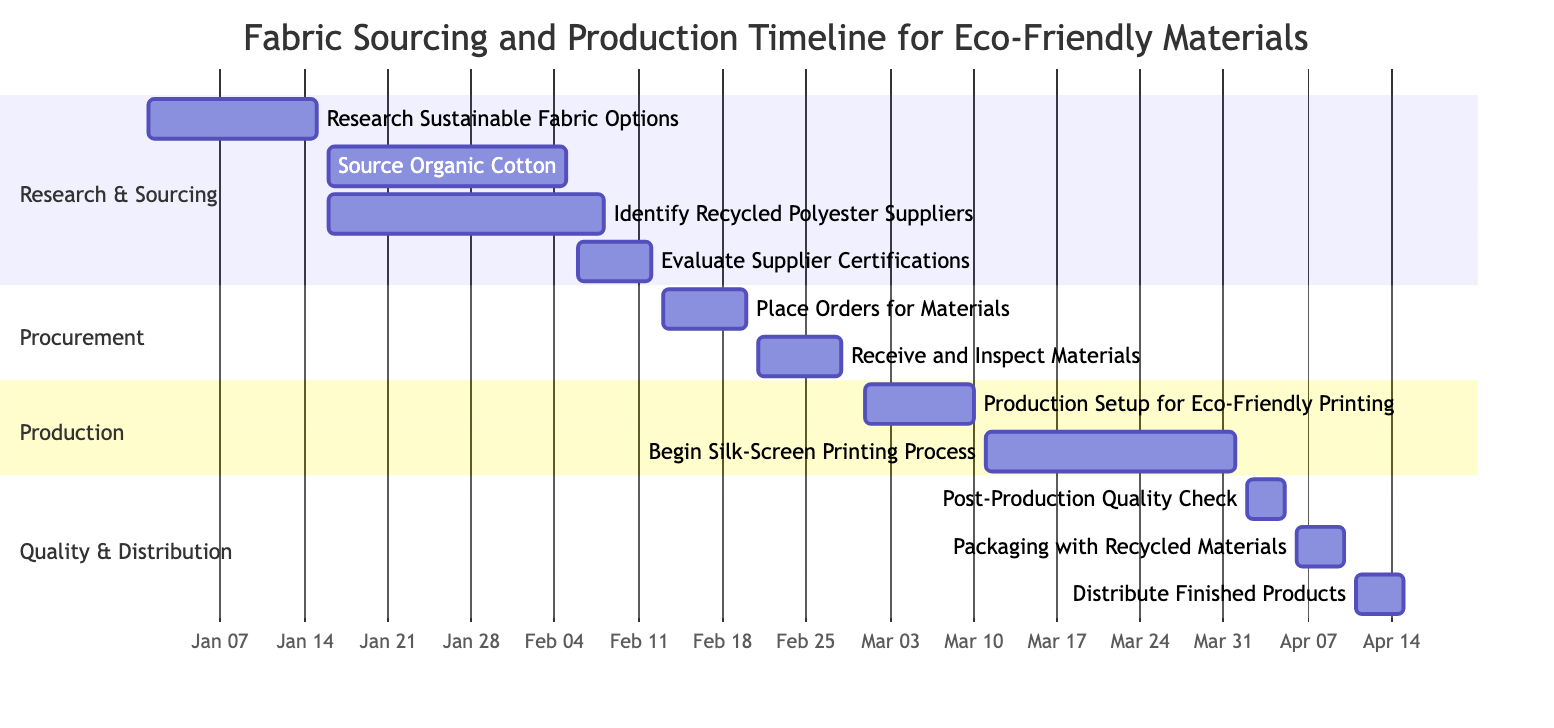What is the duration of the task "Source Organic Cotton"? The task "Source Organic Cotton" starts on January 16, 2024, and ends on February 5, 2024. To find the duration, count the days from the start date to the end date: from January 16 to February 5 is 20 days.
Answer: 20 days Which task overlaps with "Evaluate Supplier Certifications"? "Source Organic Cotton" runs from January 16 to February 5, and "Evaluate Supplier Certifications" runs from February 6 to February 12. There are no overlaps in their timelines, but it overlaps with "Identify Recycled Polyester Suppliers" which runs from January 16 to February 8.
Answer: "Identify Recycled Polyester Suppliers" How many total tasks are listed in the Gantt chart? By counting each task in the provided list, there are 11 tasks in total. Each task represents a specific part of the fabric sourcing and production process for eco-friendly materials.
Answer: 11 What task starts immediately after "Receive and Inspect Materials"? The task "Place Orders for Materials" ends on February 20, and then "Receive and Inspect Materials" starts right after, continuing until February 28. Thus, the task that starts immediately after is "Production Setup for Eco-Friendly Printing" which begins on March 1.
Answer: "Production Setup for Eco-Friendly Printing" When does the "Begin Silk-Screen Printing Process" start? The task "Begin Silk-Screen Printing Process" starts on March 11, 2024, and continues until April 1, 2024. This information can be pulled directly from the timeline provided in the Gantt chart.
Answer: March 11, 2024 What is the last task in the production timeline? Looking at the sequence of tasks in the Gantt chart, the last task listed is "Distribute Finished Products," which occurs from April 11 to April 15, 2024. This is the final phase of the process after all other tasks are completed.
Answer: "Distribute Finished Products" 